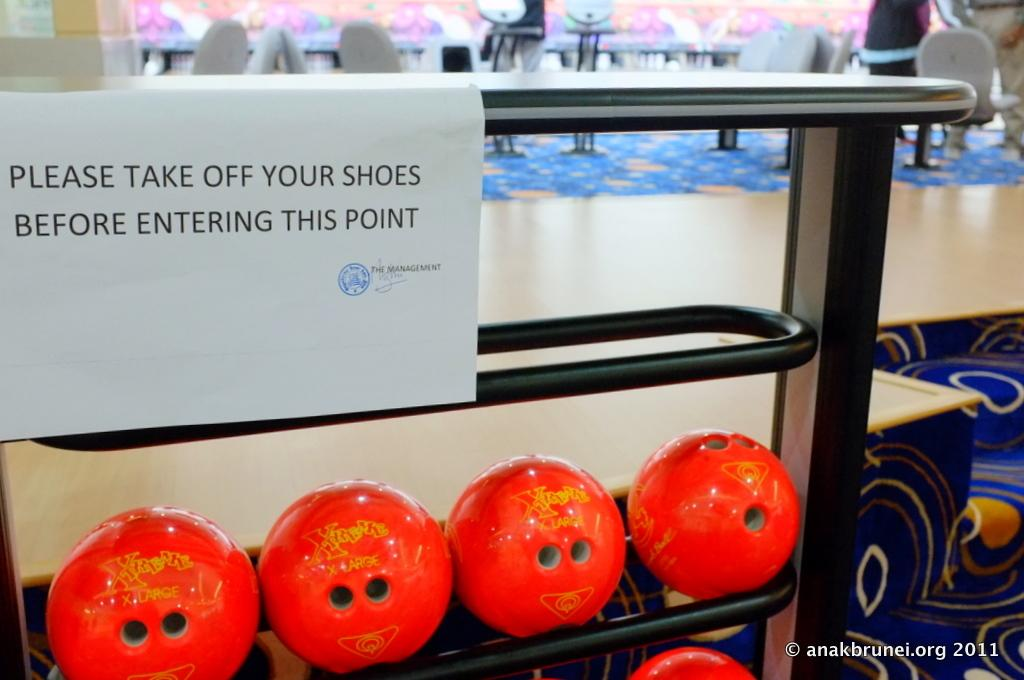What is written on the paper in the image? There is text written on a paper in the image. What can be seen at the bottom of the image? There are many red color balls at the bottom of the image. Where are the people located in the image? The people are in the top right hand corner of the image. What type of meat is being prepared in the image? There is no meat present in the image. How are the people behaving in the image? The image does not show any specific behavior of the people; they are simply located in the top right hand corner. 